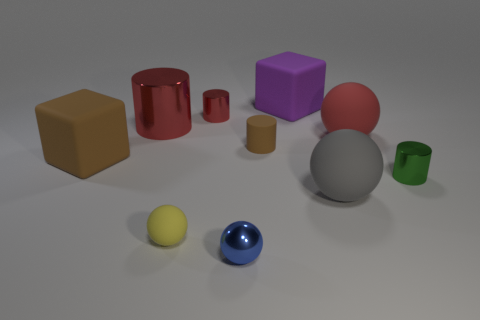How might you classify the arrangement of objects in this scene? The objects are positioned in a somewhat scattered manner but maintain a balanced composition. The varying sizes, colors, and shapes are distributed in a way that guides the eye across the scene, creating a sense of harmonious disorder. 